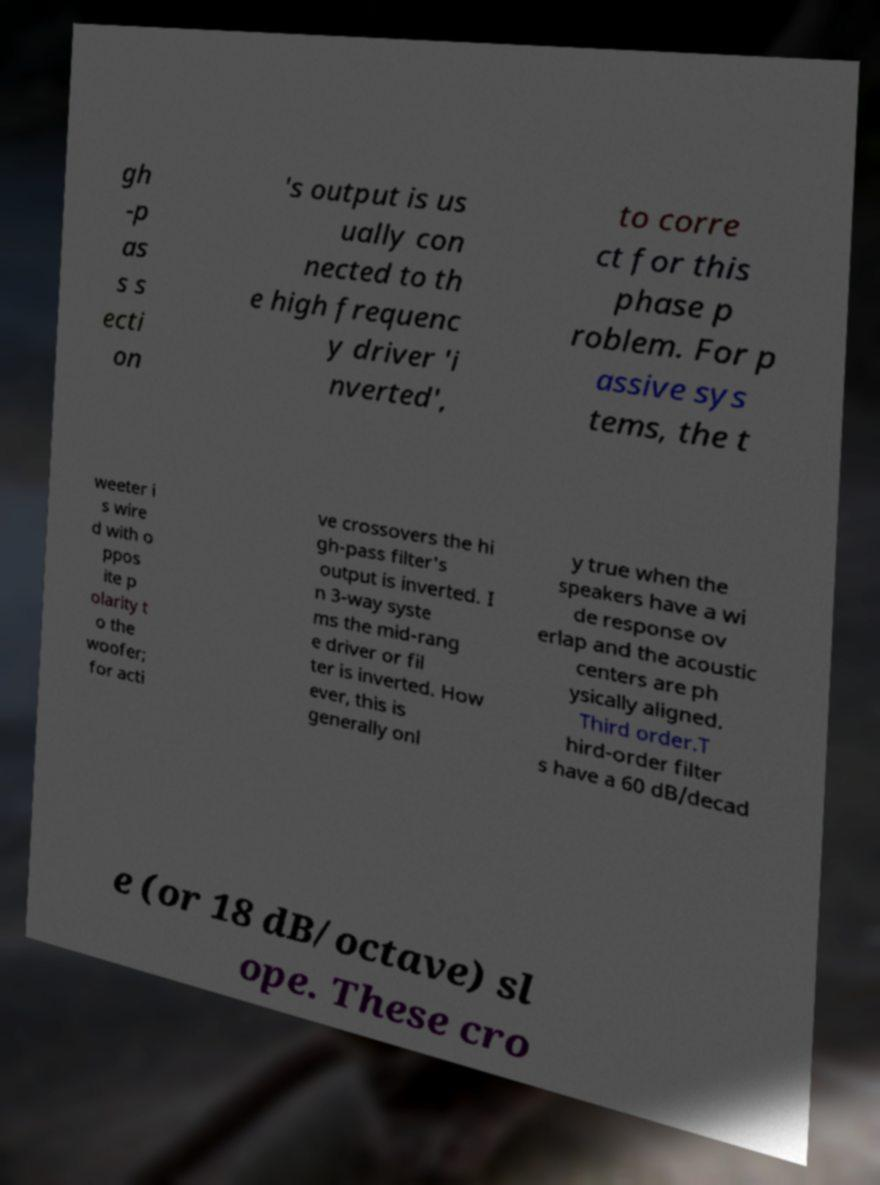Can you accurately transcribe the text from the provided image for me? gh -p as s s ecti on 's output is us ually con nected to th e high frequenc y driver 'i nverted', to corre ct for this phase p roblem. For p assive sys tems, the t weeter i s wire d with o ppos ite p olarity t o the woofer; for acti ve crossovers the hi gh-pass filter's output is inverted. I n 3-way syste ms the mid-rang e driver or fil ter is inverted. How ever, this is generally onl y true when the speakers have a wi de response ov erlap and the acoustic centers are ph ysically aligned. Third order.T hird-order filter s have a 60 dB/decad e (or 18 dB/octave) sl ope. These cro 